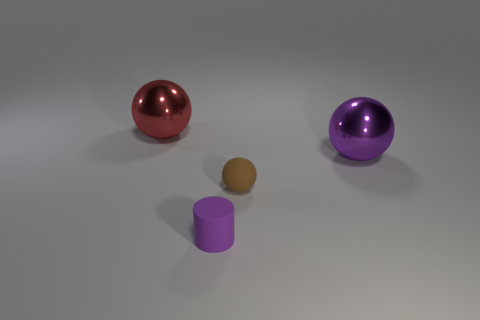Add 4 red spheres. How many objects exist? 8 Subtract all spheres. How many objects are left? 1 Subtract 1 brown spheres. How many objects are left? 3 Subtract all big things. Subtract all purple objects. How many objects are left? 0 Add 3 brown spheres. How many brown spheres are left? 4 Add 3 cylinders. How many cylinders exist? 4 